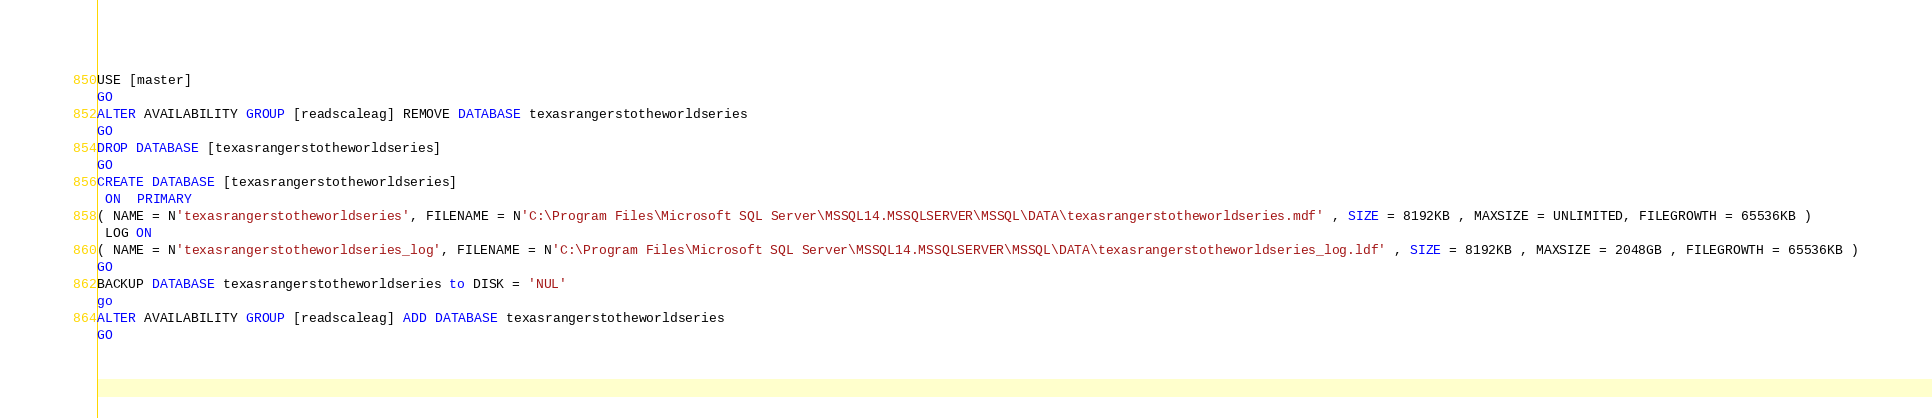Convert code to text. <code><loc_0><loc_0><loc_500><loc_500><_SQL_>USE [master]
GO
ALTER AVAILABILITY GROUP [readscaleag] REMOVE DATABASE texasrangerstotheworldseries
GO
DROP DATABASE [texasrangerstotheworldseries]
GO
CREATE DATABASE [texasrangerstotheworldseries]
 ON  PRIMARY 
( NAME = N'texasrangerstotheworldseries', FILENAME = N'C:\Program Files\Microsoft SQL Server\MSSQL14.MSSQLSERVER\MSSQL\DATA\texasrangerstotheworldseries.mdf' , SIZE = 8192KB , MAXSIZE = UNLIMITED, FILEGROWTH = 65536KB )
 LOG ON 
( NAME = N'texasrangerstotheworldseries_log', FILENAME = N'C:\Program Files\Microsoft SQL Server\MSSQL14.MSSQLSERVER\MSSQL\DATA\texasrangerstotheworldseries_log.ldf' , SIZE = 8192KB , MAXSIZE = 2048GB , FILEGROWTH = 65536KB )
GO
BACKUP DATABASE texasrangerstotheworldseries to DISK = 'NUL'
go
ALTER AVAILABILITY GROUP [readscaleag] ADD DATABASE texasrangerstotheworldseries
GO</code> 